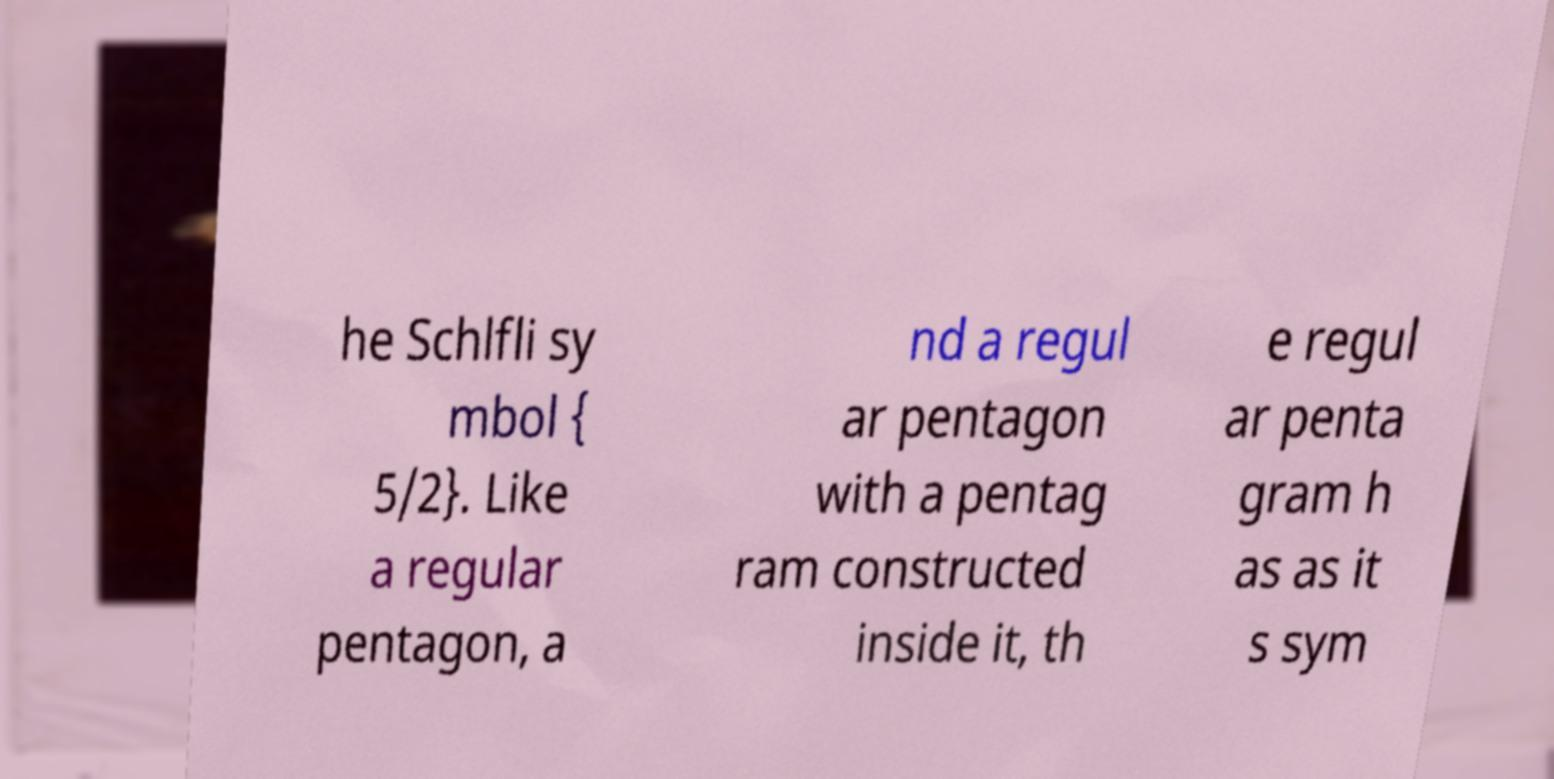Can you accurately transcribe the text from the provided image for me? he Schlfli sy mbol { 5/2}. Like a regular pentagon, a nd a regul ar pentagon with a pentag ram constructed inside it, th e regul ar penta gram h as as it s sym 